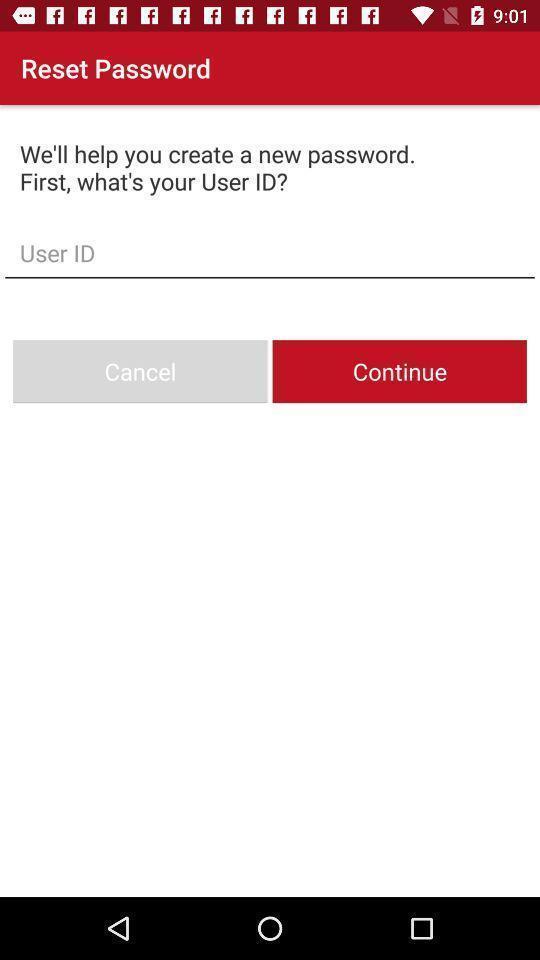What can you discern from this picture? Screen to reset password. 